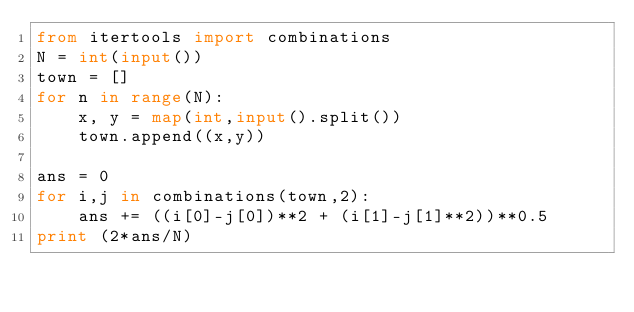Convert code to text. <code><loc_0><loc_0><loc_500><loc_500><_Python_>from itertools import combinations
N = int(input())
town = []
for n in range(N):
    x, y = map(int,input().split())
    town.append((x,y))

ans = 0
for i,j in combinations(town,2):
    ans += ((i[0]-j[0])**2 + (i[1]-j[1]**2))**0.5
print (2*ans/N)</code> 